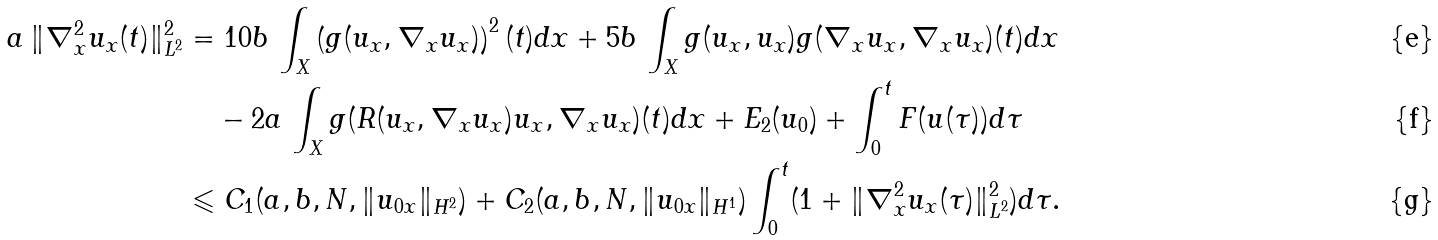Convert formula to latex. <formula><loc_0><loc_0><loc_500><loc_500>a \, \| \nabla _ { x } ^ { 2 } u _ { x } ( t ) \| _ { L ^ { 2 } } ^ { 2 } & = 1 0 b \, \int _ { X } \left ( g ( u _ { x } , \nabla _ { x } u _ { x } ) \right ) ^ { 2 } ( t ) d x + 5 b \, \int _ { X } g ( u _ { x } , u _ { x } ) g ( \nabla _ { x } u _ { x } , \nabla _ { x } u _ { x } ) ( t ) d x \\ & \quad - 2 a \, \int _ { X } g ( R ( u _ { x } , \nabla _ { x } u _ { x } ) u _ { x } , \nabla _ { x } u _ { x } ) ( t ) d x + E _ { 2 } ( u _ { 0 } ) + \int _ { 0 } ^ { t } F ( u ( \tau ) ) d \tau \\ & \leqslant C _ { 1 } ( a , b , N , \| u _ { 0 x } \| _ { H ^ { 2 } } ) + C _ { 2 } ( a , b , N , \| u _ { 0 x } \| _ { H ^ { 1 } } ) \int _ { 0 } ^ { t } ( 1 + \| \nabla _ { x } ^ { 2 } u _ { x } ( \tau ) \| _ { L ^ { 2 } } ^ { 2 } ) d \tau .</formula> 